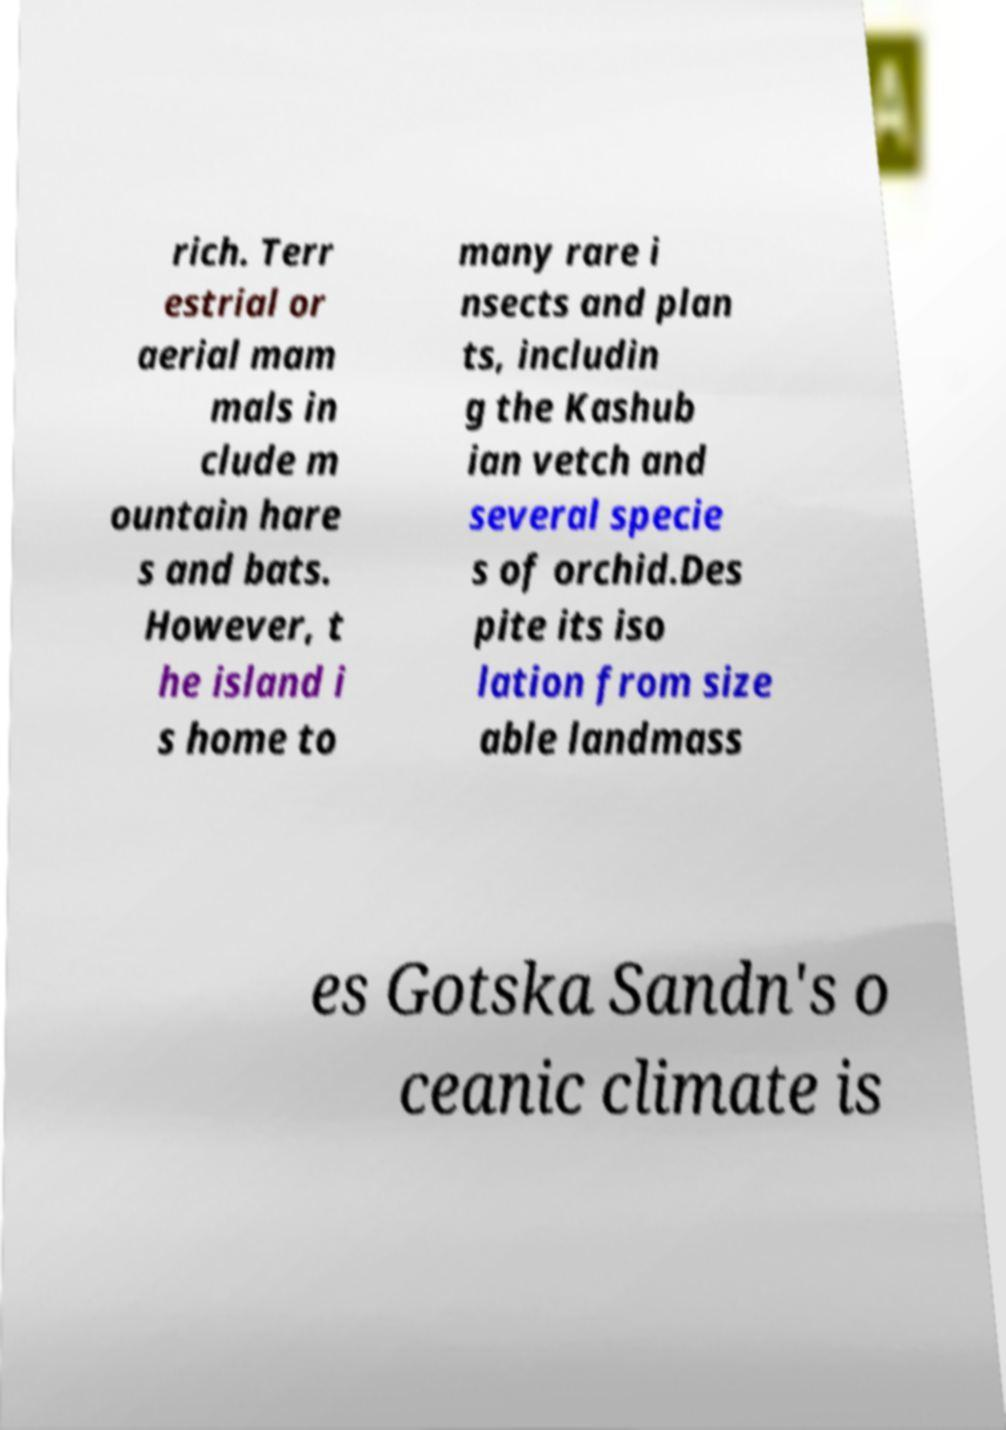Please identify and transcribe the text found in this image. rich. Terr estrial or aerial mam mals in clude m ountain hare s and bats. However, t he island i s home to many rare i nsects and plan ts, includin g the Kashub ian vetch and several specie s of orchid.Des pite its iso lation from size able landmass es Gotska Sandn's o ceanic climate is 